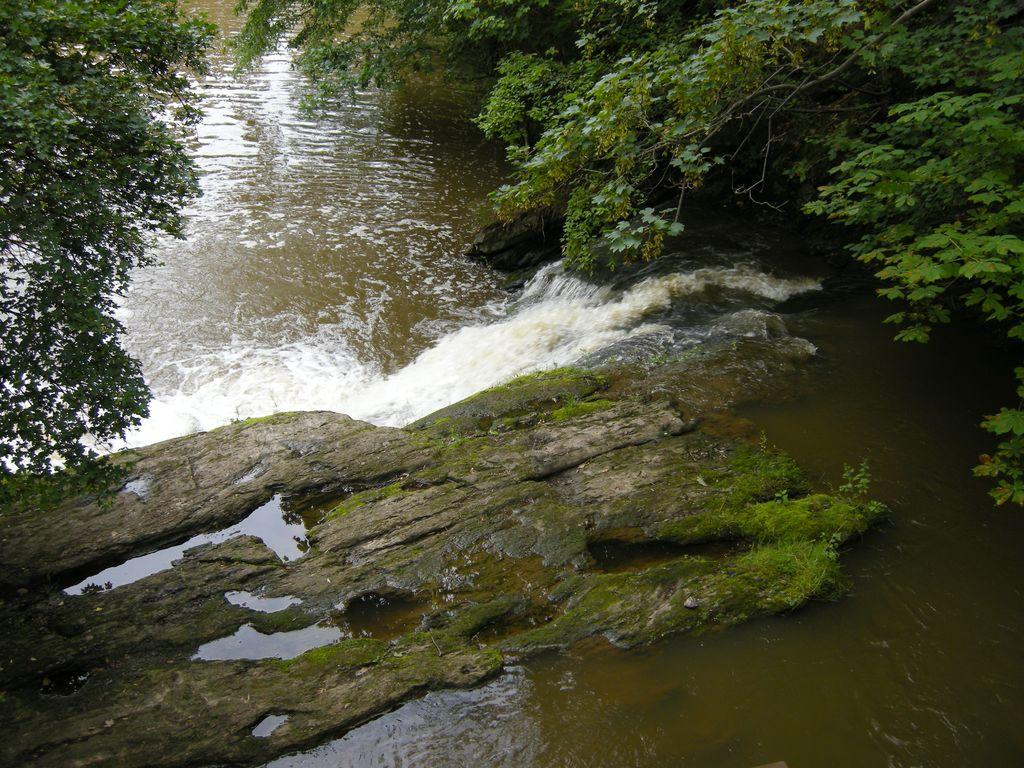What type of natural feature is present in the image? There is a river in the image. What can be seen around the river? There are trees around the river. What is the surface in the foreground of the image? There is a rock surface in the foreground of the image. What type of brick structure can be seen near the river in the image? There is no brick structure present in the image; it features a river, trees, and a rock surface. 